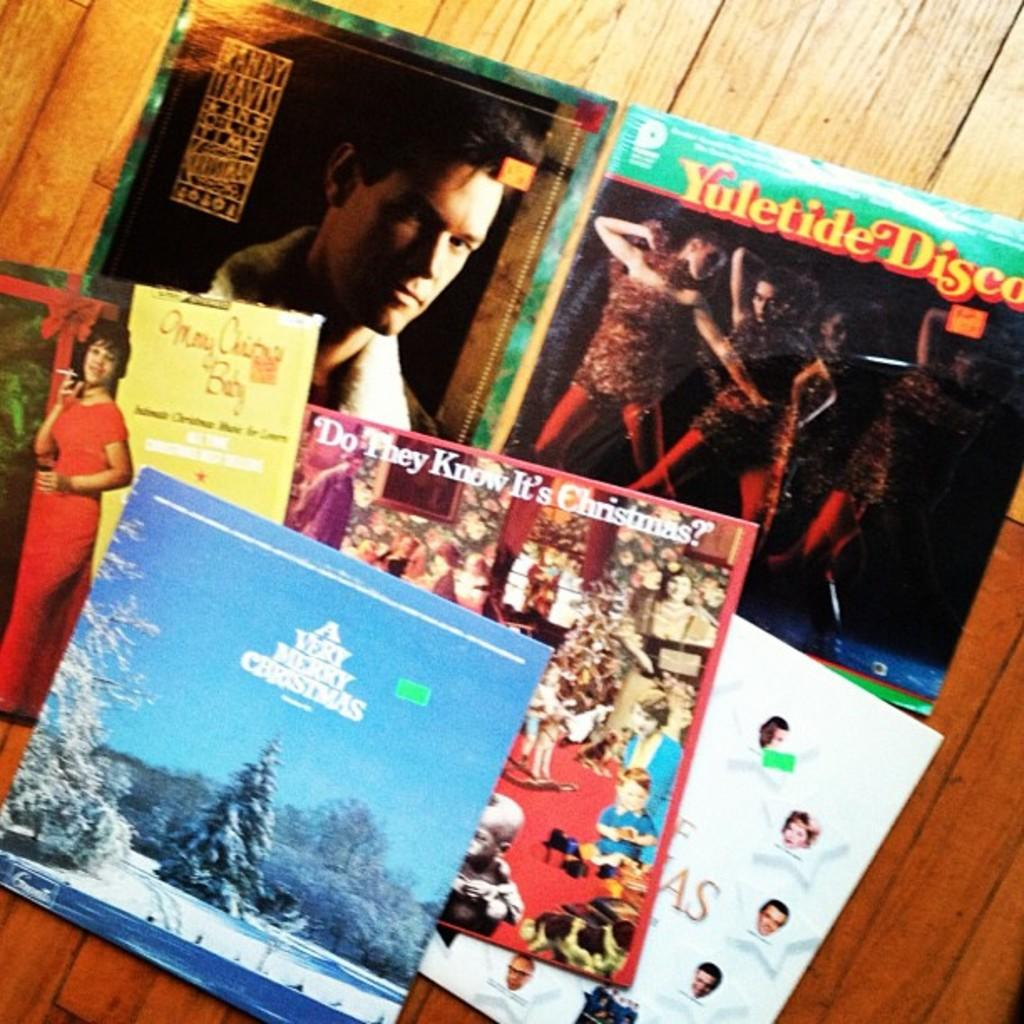<image>
Describe the image concisely. A cover of Yuletide Dancer is on the floor. 